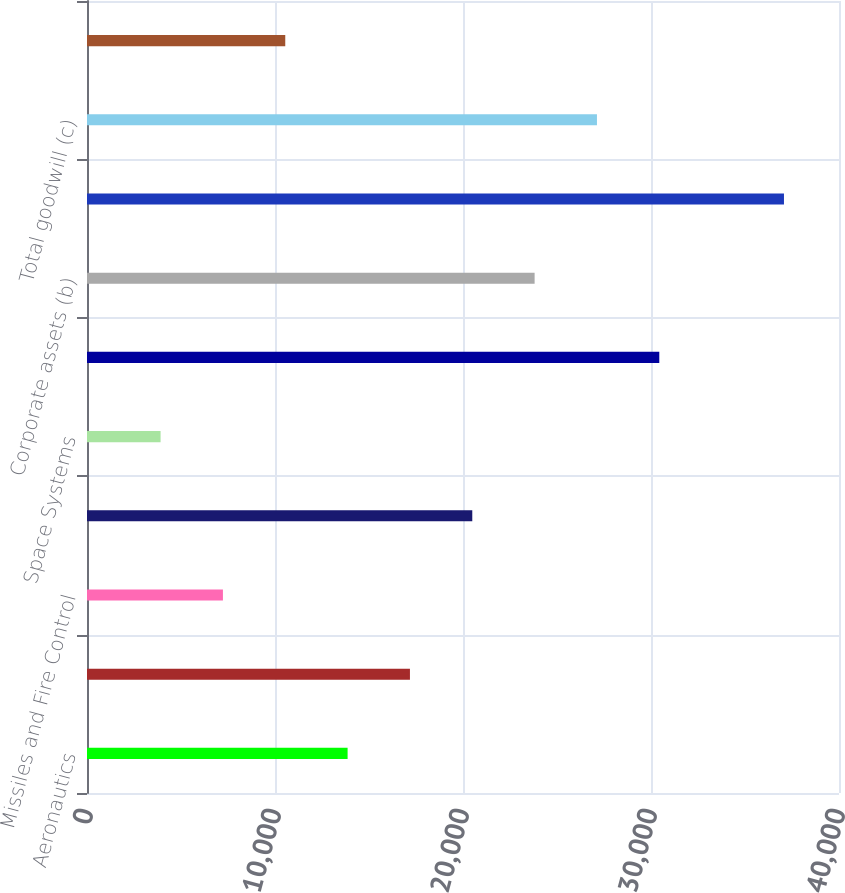Convert chart to OTSL. <chart><loc_0><loc_0><loc_500><loc_500><bar_chart><fcel>Aeronautics<fcel>Information Systems & Global<fcel>Missiles and Fire Control<fcel>Mission Systems and Training<fcel>Space Systems<fcel>Total business segment assets<fcel>Corporate assets (b)<fcel>Total assets<fcel>Total goodwill (c)<fcel>Total customer advances and<nl><fcel>13861.7<fcel>17177.6<fcel>7229.9<fcel>20493.5<fcel>3914<fcel>30441.2<fcel>23809.4<fcel>37073<fcel>27125.3<fcel>10545.8<nl></chart> 